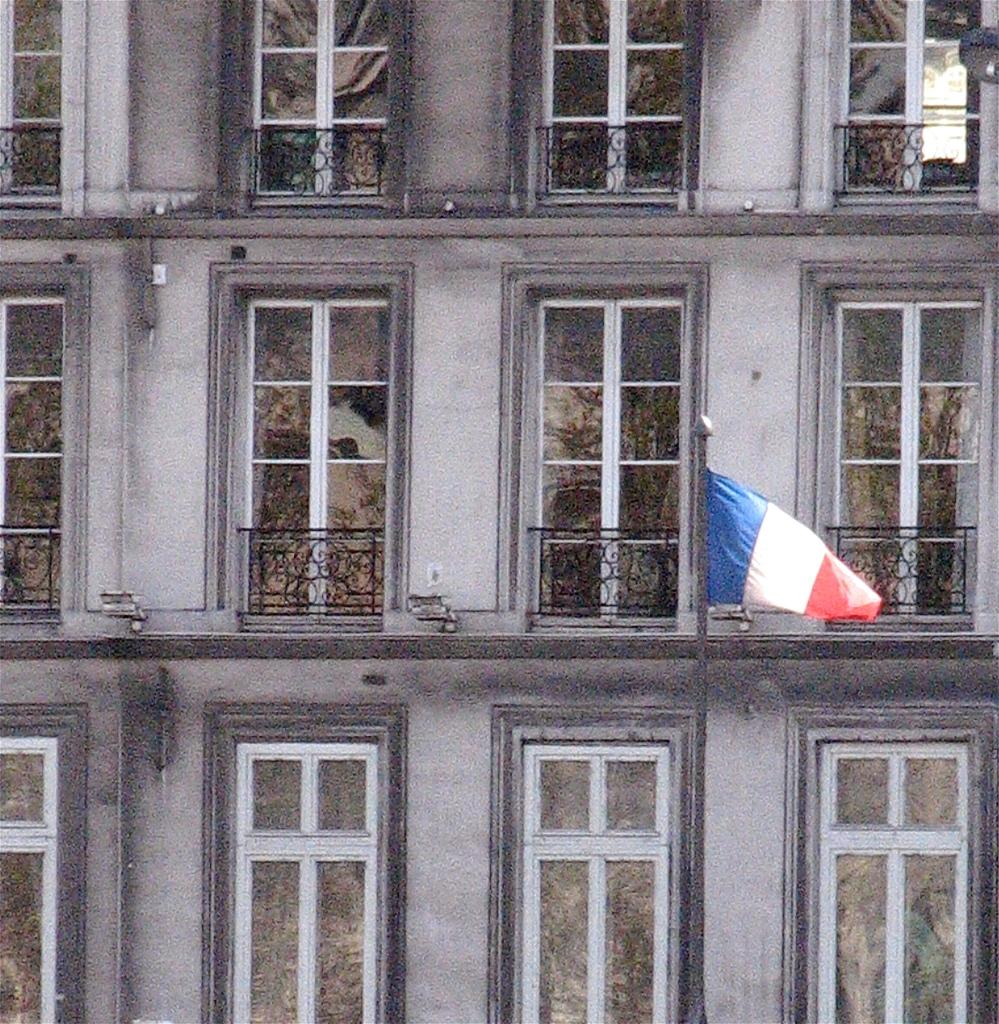What type of structure is visible in the image? There is a building in the image. What is attached to the flag post in the image? There is a flag in the image. What part of the building can be seen in the image? There are windows in the image. What type of cooking equipment is present in the image? There are grills in the image. What type of shoes can be seen on the flag in the image? There are no shoes present in the image, as the flag is not a footwear item. 